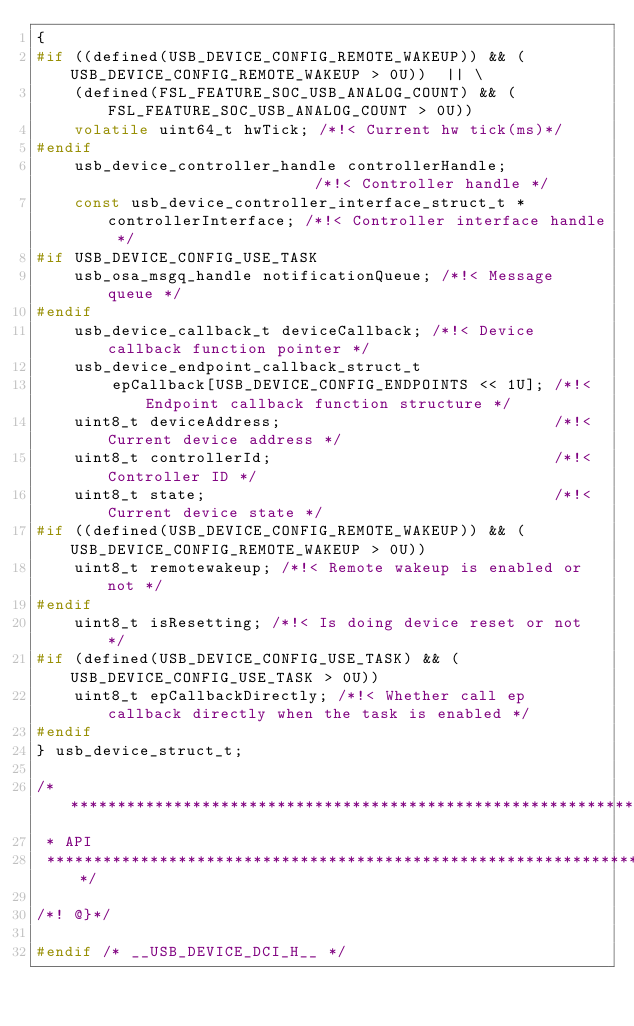<code> <loc_0><loc_0><loc_500><loc_500><_C_>{
#if ((defined(USB_DEVICE_CONFIG_REMOTE_WAKEUP)) && (USB_DEVICE_CONFIG_REMOTE_WAKEUP > 0U))  || \
    (defined(FSL_FEATURE_SOC_USB_ANALOG_COUNT) && (FSL_FEATURE_SOC_USB_ANALOG_COUNT > 0U))
    volatile uint64_t hwTick; /*!< Current hw tick(ms)*/
#endif
    usb_device_controller_handle controllerHandle;                       /*!< Controller handle */
    const usb_device_controller_interface_struct_t *controllerInterface; /*!< Controller interface handle */
#if USB_DEVICE_CONFIG_USE_TASK
    usb_osa_msgq_handle notificationQueue; /*!< Message queue */
#endif
    usb_device_callback_t deviceCallback; /*!< Device callback function pointer */
    usb_device_endpoint_callback_struct_t
        epCallback[USB_DEVICE_CONFIG_ENDPOINTS << 1U]; /*!< Endpoint callback function structure */
    uint8_t deviceAddress;                             /*!< Current device address */
    uint8_t controllerId;                              /*!< Controller ID */
    uint8_t state;                                     /*!< Current device state */
#if ((defined(USB_DEVICE_CONFIG_REMOTE_WAKEUP)) && (USB_DEVICE_CONFIG_REMOTE_WAKEUP > 0U))
    uint8_t remotewakeup; /*!< Remote wakeup is enabled or not */
#endif
    uint8_t isResetting; /*!< Is doing device reset or not */
#if (defined(USB_DEVICE_CONFIG_USE_TASK) && (USB_DEVICE_CONFIG_USE_TASK > 0U))
    uint8_t epCallbackDirectly; /*!< Whether call ep callback directly when the task is enabled */
#endif
} usb_device_struct_t;

/*******************************************************************************
 * API
 ******************************************************************************/

/*! @}*/

#endif /* __USB_DEVICE_DCI_H__ */
</code> 